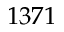Convert formula to latex. <formula><loc_0><loc_0><loc_500><loc_500>1 3 7 1</formula> 